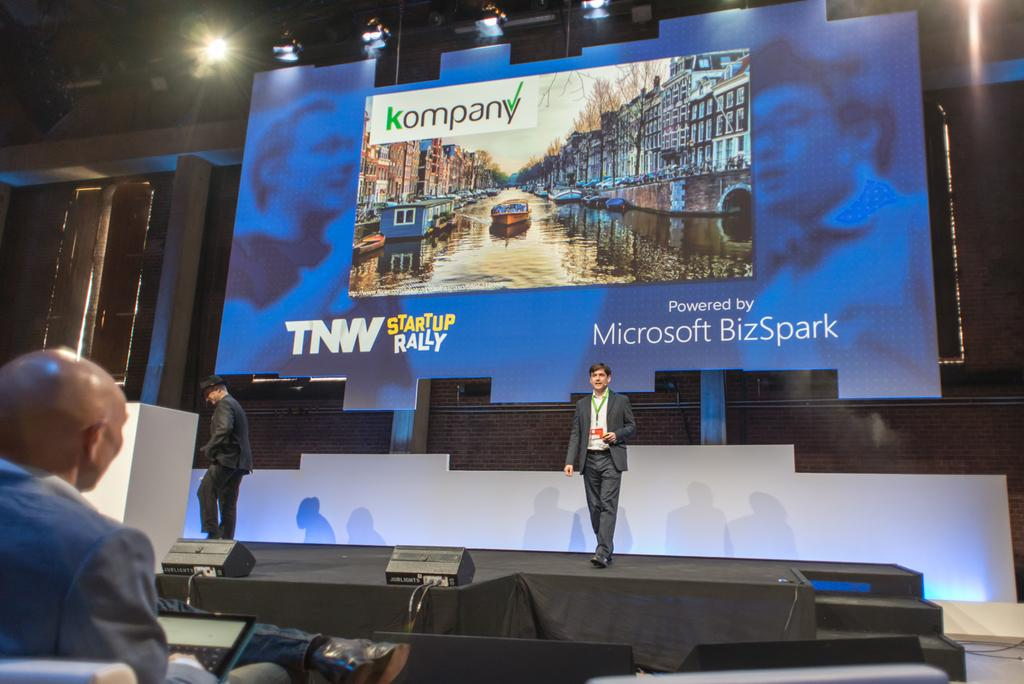<image>
Render a clear and concise summary of the photo. Two men stand in front of a screen that indicates it is powered by Microsoft BizSpark. 